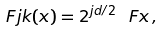Convert formula to latex. <formula><loc_0><loc_0><loc_500><loc_500>\ F j k ( x ) = 2 ^ { j d / 2 } \ F x \, ,</formula> 